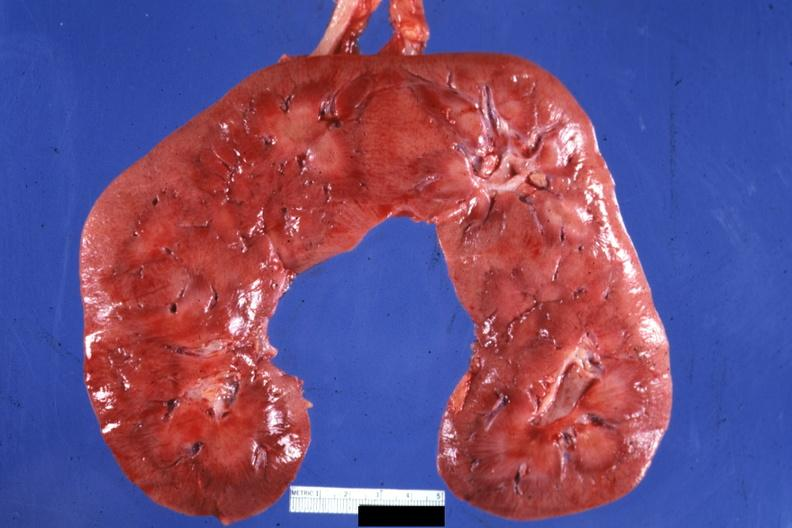what does this image show?
Answer the question using a single word or phrase. Frontal section quite good 